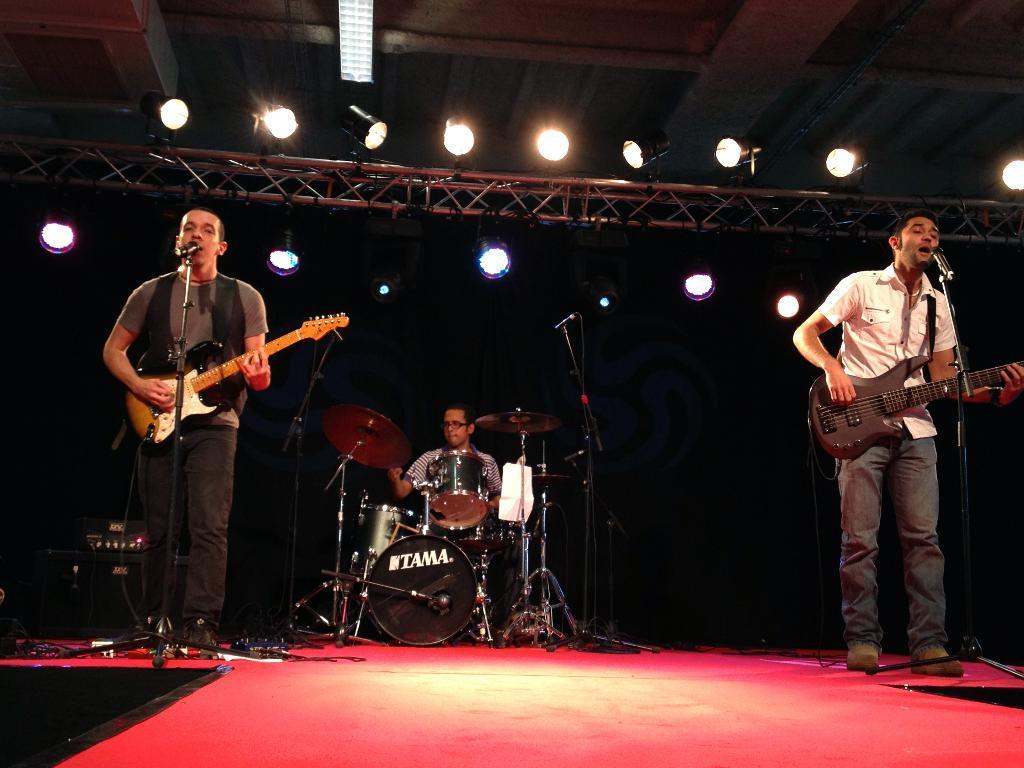In one or two sentences, can you explain what this image depicts? Here we can see two men playing guitars and singing songs in the microphone present in front of them and in the middle we can see a person playing drums and above them we can see lights present 